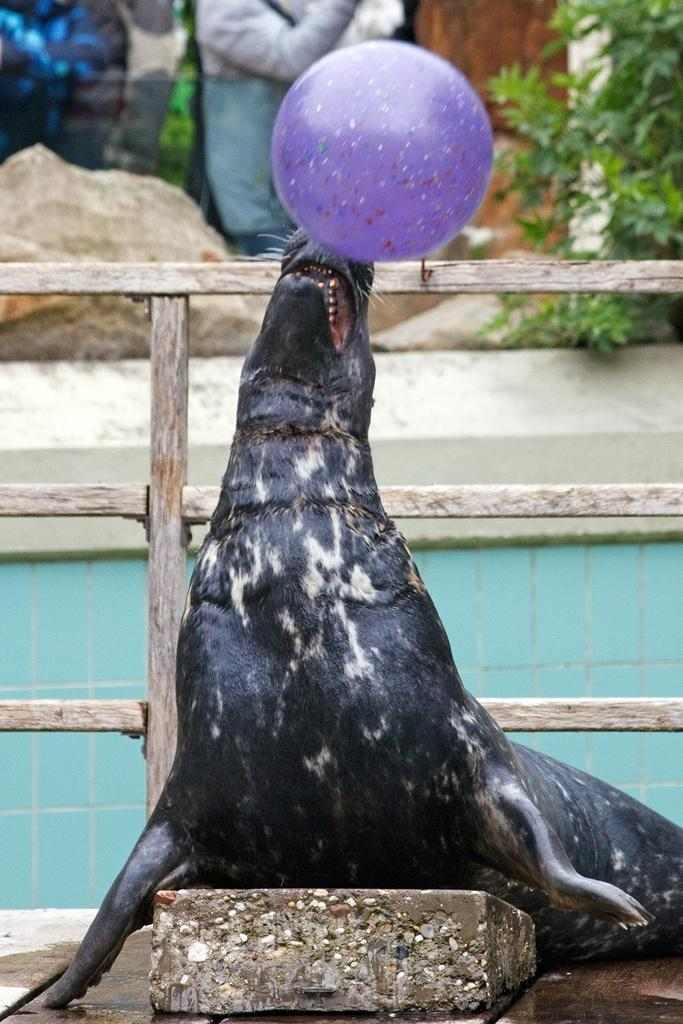What animal is playing with a ball in the image? A seal is playing with a ball in the image. What type of barrier is visible in the image? There is a wooden fence in the image. What type of vegetation is present in the image? There is a plant in the image. What type of natural feature is present in the image? There is a rock in the image. What type of business is being conducted in the image? There is no indication of any business activity in the image. What type of flame can be seen in the image? There is no flame present in the image. 